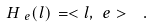<formula> <loc_0><loc_0><loc_500><loc_500>H _ { \ e } ( l ) \, = < l , \ e > \ \ .</formula> 